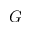Convert formula to latex. <formula><loc_0><loc_0><loc_500><loc_500>G</formula> 